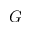Convert formula to latex. <formula><loc_0><loc_0><loc_500><loc_500>G</formula> 